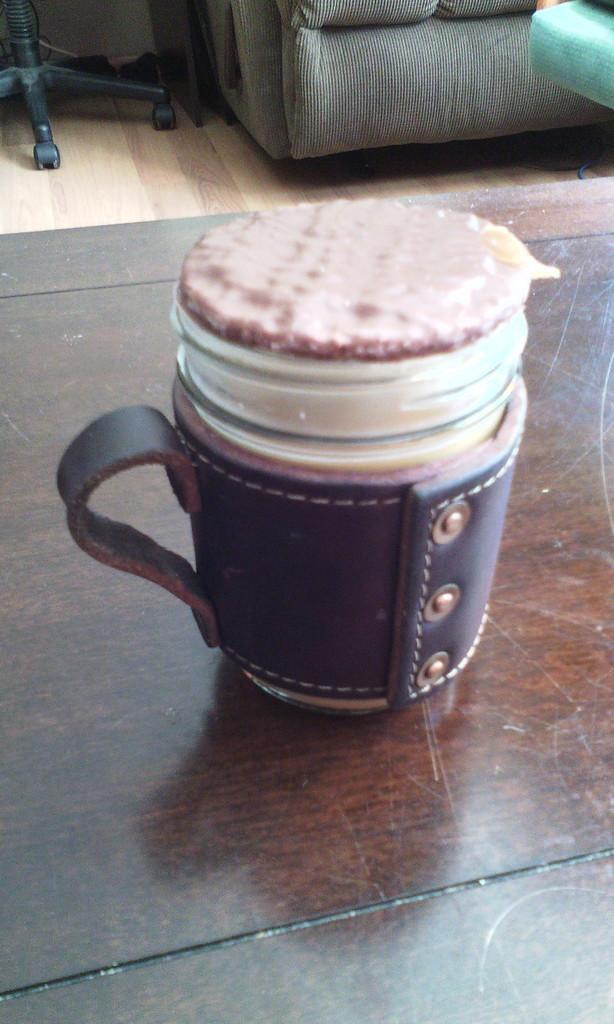What is on the table in the image? There is a cup on the table in the image. What is inside the cup? The cup contains some desert. What type of furniture can be seen in the background of the image? There is a sofa and a chair in the background of the image. What type of list is being compiled by the company in the image? There is no company or list present in the image; it only features a cup, desert, a sofa, and a chair. 